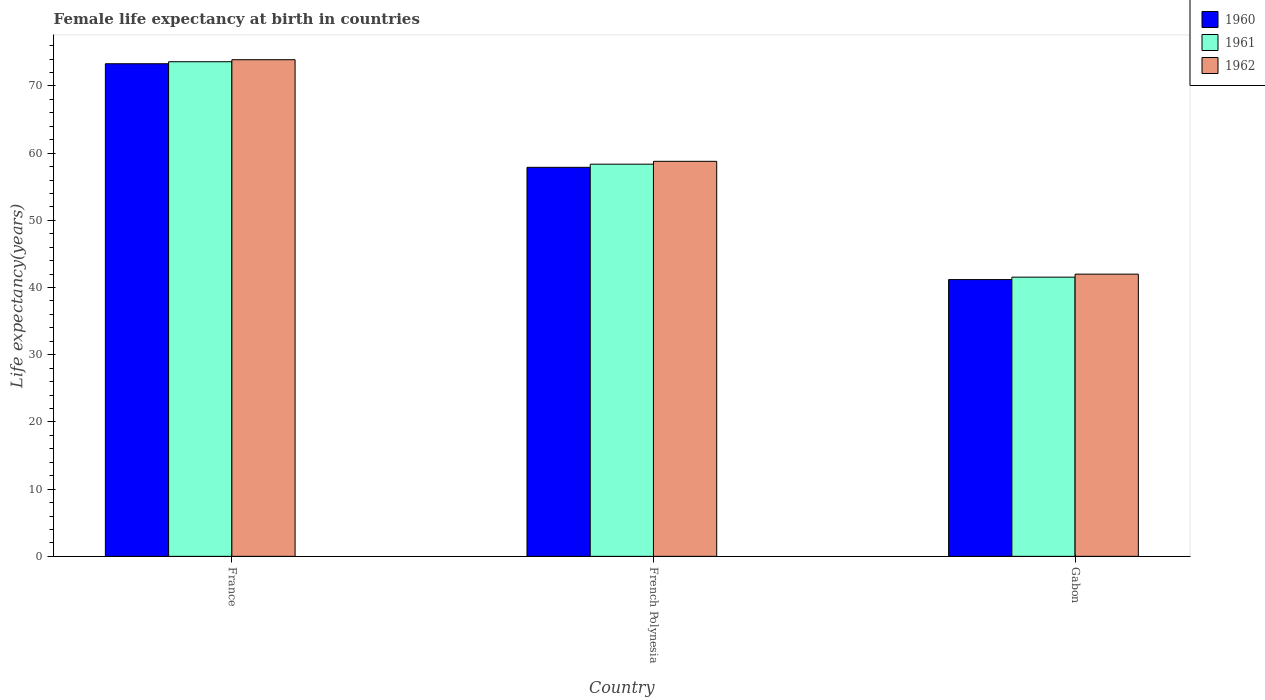How many different coloured bars are there?
Ensure brevity in your answer.  3. Are the number of bars per tick equal to the number of legend labels?
Your answer should be very brief. Yes. Are the number of bars on each tick of the X-axis equal?
Give a very brief answer. Yes. How many bars are there on the 3rd tick from the left?
Your answer should be very brief. 3. How many bars are there on the 1st tick from the right?
Make the answer very short. 3. What is the label of the 1st group of bars from the left?
Offer a very short reply. France. In how many cases, is the number of bars for a given country not equal to the number of legend labels?
Make the answer very short. 0. What is the female life expectancy at birth in 1960 in French Polynesia?
Offer a terse response. 57.89. Across all countries, what is the maximum female life expectancy at birth in 1961?
Keep it short and to the point. 73.6. Across all countries, what is the minimum female life expectancy at birth in 1962?
Give a very brief answer. 41.99. In which country was the female life expectancy at birth in 1962 minimum?
Give a very brief answer. Gabon. What is the total female life expectancy at birth in 1961 in the graph?
Provide a succinct answer. 173.5. What is the difference between the female life expectancy at birth in 1962 in France and that in French Polynesia?
Make the answer very short. 15.12. What is the difference between the female life expectancy at birth in 1960 in Gabon and the female life expectancy at birth in 1962 in France?
Offer a terse response. -32.72. What is the average female life expectancy at birth in 1961 per country?
Your answer should be very brief. 57.83. What is the difference between the female life expectancy at birth of/in 1961 and female life expectancy at birth of/in 1960 in French Polynesia?
Provide a short and direct response. 0.47. In how many countries, is the female life expectancy at birth in 1962 greater than 30 years?
Provide a succinct answer. 3. What is the ratio of the female life expectancy at birth in 1960 in French Polynesia to that in Gabon?
Your answer should be very brief. 1.41. Is the difference between the female life expectancy at birth in 1961 in France and French Polynesia greater than the difference between the female life expectancy at birth in 1960 in France and French Polynesia?
Ensure brevity in your answer.  No. What is the difference between the highest and the second highest female life expectancy at birth in 1962?
Your answer should be compact. 15.12. What is the difference between the highest and the lowest female life expectancy at birth in 1961?
Ensure brevity in your answer.  32.06. Is the sum of the female life expectancy at birth in 1961 in French Polynesia and Gabon greater than the maximum female life expectancy at birth in 1962 across all countries?
Offer a very short reply. Yes. How many countries are there in the graph?
Offer a very short reply. 3. What is the difference between two consecutive major ticks on the Y-axis?
Your answer should be very brief. 10. Does the graph contain grids?
Your answer should be very brief. No. Where does the legend appear in the graph?
Provide a succinct answer. Top right. How are the legend labels stacked?
Make the answer very short. Vertical. What is the title of the graph?
Your answer should be very brief. Female life expectancy at birth in countries. Does "1981" appear as one of the legend labels in the graph?
Provide a short and direct response. No. What is the label or title of the Y-axis?
Offer a very short reply. Life expectancy(years). What is the Life expectancy(years) of 1960 in France?
Ensure brevity in your answer.  73.3. What is the Life expectancy(years) in 1961 in France?
Give a very brief answer. 73.6. What is the Life expectancy(years) in 1962 in France?
Offer a terse response. 73.9. What is the Life expectancy(years) of 1960 in French Polynesia?
Keep it short and to the point. 57.89. What is the Life expectancy(years) of 1961 in French Polynesia?
Keep it short and to the point. 58.35. What is the Life expectancy(years) in 1962 in French Polynesia?
Give a very brief answer. 58.78. What is the Life expectancy(years) of 1960 in Gabon?
Keep it short and to the point. 41.18. What is the Life expectancy(years) in 1961 in Gabon?
Your answer should be very brief. 41.54. What is the Life expectancy(years) in 1962 in Gabon?
Make the answer very short. 41.99. Across all countries, what is the maximum Life expectancy(years) in 1960?
Ensure brevity in your answer.  73.3. Across all countries, what is the maximum Life expectancy(years) of 1961?
Give a very brief answer. 73.6. Across all countries, what is the maximum Life expectancy(years) in 1962?
Your response must be concise. 73.9. Across all countries, what is the minimum Life expectancy(years) of 1960?
Your response must be concise. 41.18. Across all countries, what is the minimum Life expectancy(years) in 1961?
Your response must be concise. 41.54. Across all countries, what is the minimum Life expectancy(years) of 1962?
Make the answer very short. 41.99. What is the total Life expectancy(years) of 1960 in the graph?
Ensure brevity in your answer.  172.37. What is the total Life expectancy(years) in 1961 in the graph?
Offer a terse response. 173.5. What is the total Life expectancy(years) of 1962 in the graph?
Give a very brief answer. 174.67. What is the difference between the Life expectancy(years) of 1960 in France and that in French Polynesia?
Ensure brevity in your answer.  15.41. What is the difference between the Life expectancy(years) in 1961 in France and that in French Polynesia?
Offer a very short reply. 15.25. What is the difference between the Life expectancy(years) of 1962 in France and that in French Polynesia?
Give a very brief answer. 15.12. What is the difference between the Life expectancy(years) of 1960 in France and that in Gabon?
Make the answer very short. 32.12. What is the difference between the Life expectancy(years) of 1961 in France and that in Gabon?
Provide a short and direct response. 32.06. What is the difference between the Life expectancy(years) in 1962 in France and that in Gabon?
Provide a short and direct response. 31.91. What is the difference between the Life expectancy(years) of 1960 in French Polynesia and that in Gabon?
Make the answer very short. 16.71. What is the difference between the Life expectancy(years) in 1961 in French Polynesia and that in Gabon?
Ensure brevity in your answer.  16.81. What is the difference between the Life expectancy(years) in 1962 in French Polynesia and that in Gabon?
Ensure brevity in your answer.  16.79. What is the difference between the Life expectancy(years) in 1960 in France and the Life expectancy(years) in 1961 in French Polynesia?
Keep it short and to the point. 14.95. What is the difference between the Life expectancy(years) in 1960 in France and the Life expectancy(years) in 1962 in French Polynesia?
Make the answer very short. 14.52. What is the difference between the Life expectancy(years) in 1961 in France and the Life expectancy(years) in 1962 in French Polynesia?
Provide a short and direct response. 14.82. What is the difference between the Life expectancy(years) of 1960 in France and the Life expectancy(years) of 1961 in Gabon?
Make the answer very short. 31.76. What is the difference between the Life expectancy(years) of 1960 in France and the Life expectancy(years) of 1962 in Gabon?
Provide a short and direct response. 31.31. What is the difference between the Life expectancy(years) in 1961 in France and the Life expectancy(years) in 1962 in Gabon?
Provide a short and direct response. 31.61. What is the difference between the Life expectancy(years) in 1960 in French Polynesia and the Life expectancy(years) in 1961 in Gabon?
Provide a short and direct response. 16.34. What is the difference between the Life expectancy(years) of 1960 in French Polynesia and the Life expectancy(years) of 1962 in Gabon?
Your answer should be very brief. 15.9. What is the difference between the Life expectancy(years) of 1961 in French Polynesia and the Life expectancy(years) of 1962 in Gabon?
Provide a short and direct response. 16.36. What is the average Life expectancy(years) in 1960 per country?
Offer a very short reply. 57.46. What is the average Life expectancy(years) in 1961 per country?
Your answer should be very brief. 57.83. What is the average Life expectancy(years) in 1962 per country?
Keep it short and to the point. 58.22. What is the difference between the Life expectancy(years) of 1960 and Life expectancy(years) of 1961 in France?
Your answer should be compact. -0.3. What is the difference between the Life expectancy(years) in 1960 and Life expectancy(years) in 1961 in French Polynesia?
Your answer should be compact. -0.47. What is the difference between the Life expectancy(years) of 1960 and Life expectancy(years) of 1962 in French Polynesia?
Offer a terse response. -0.89. What is the difference between the Life expectancy(years) of 1961 and Life expectancy(years) of 1962 in French Polynesia?
Offer a very short reply. -0.43. What is the difference between the Life expectancy(years) of 1960 and Life expectancy(years) of 1961 in Gabon?
Provide a succinct answer. -0.36. What is the difference between the Life expectancy(years) of 1960 and Life expectancy(years) of 1962 in Gabon?
Give a very brief answer. -0.81. What is the difference between the Life expectancy(years) in 1961 and Life expectancy(years) in 1962 in Gabon?
Your response must be concise. -0.45. What is the ratio of the Life expectancy(years) in 1960 in France to that in French Polynesia?
Ensure brevity in your answer.  1.27. What is the ratio of the Life expectancy(years) in 1961 in France to that in French Polynesia?
Offer a very short reply. 1.26. What is the ratio of the Life expectancy(years) in 1962 in France to that in French Polynesia?
Offer a terse response. 1.26. What is the ratio of the Life expectancy(years) of 1960 in France to that in Gabon?
Ensure brevity in your answer.  1.78. What is the ratio of the Life expectancy(years) in 1961 in France to that in Gabon?
Offer a very short reply. 1.77. What is the ratio of the Life expectancy(years) in 1962 in France to that in Gabon?
Offer a terse response. 1.76. What is the ratio of the Life expectancy(years) of 1960 in French Polynesia to that in Gabon?
Your response must be concise. 1.41. What is the ratio of the Life expectancy(years) of 1961 in French Polynesia to that in Gabon?
Your answer should be compact. 1.4. What is the ratio of the Life expectancy(years) in 1962 in French Polynesia to that in Gabon?
Offer a terse response. 1.4. What is the difference between the highest and the second highest Life expectancy(years) in 1960?
Keep it short and to the point. 15.41. What is the difference between the highest and the second highest Life expectancy(years) in 1961?
Ensure brevity in your answer.  15.25. What is the difference between the highest and the second highest Life expectancy(years) in 1962?
Your answer should be compact. 15.12. What is the difference between the highest and the lowest Life expectancy(years) of 1960?
Give a very brief answer. 32.12. What is the difference between the highest and the lowest Life expectancy(years) of 1961?
Offer a terse response. 32.06. What is the difference between the highest and the lowest Life expectancy(years) in 1962?
Make the answer very short. 31.91. 